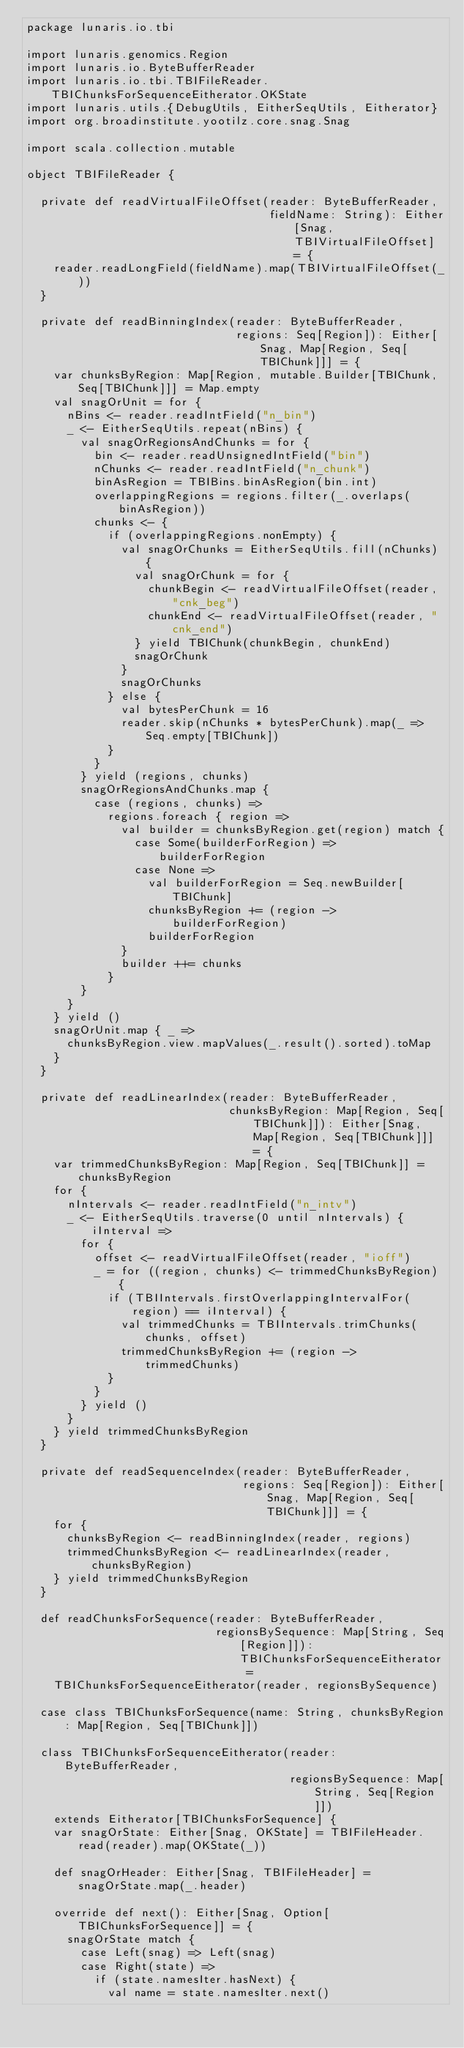Convert code to text. <code><loc_0><loc_0><loc_500><loc_500><_Scala_>package lunaris.io.tbi

import lunaris.genomics.Region
import lunaris.io.ByteBufferReader
import lunaris.io.tbi.TBIFileReader.TBIChunksForSequenceEitherator.OKState
import lunaris.utils.{DebugUtils, EitherSeqUtils, Eitherator}
import org.broadinstitute.yootilz.core.snag.Snag

import scala.collection.mutable

object TBIFileReader {

  private def readVirtualFileOffset(reader: ByteBufferReader,
                                    fieldName: String): Either[Snag, TBIVirtualFileOffset] = {
    reader.readLongField(fieldName).map(TBIVirtualFileOffset(_))
  }

  private def readBinningIndex(reader: ByteBufferReader,
                               regions: Seq[Region]): Either[Snag, Map[Region, Seq[TBIChunk]]] = {
    var chunksByRegion: Map[Region, mutable.Builder[TBIChunk, Seq[TBIChunk]]] = Map.empty
    val snagOrUnit = for {
      nBins <- reader.readIntField("n_bin")
      _ <- EitherSeqUtils.repeat(nBins) {
        val snagOrRegionsAndChunks = for {
          bin <- reader.readUnsignedIntField("bin")
          nChunks <- reader.readIntField("n_chunk")
          binAsRegion = TBIBins.binAsRegion(bin.int)
          overlappingRegions = regions.filter(_.overlaps(binAsRegion))
          chunks <- {
            if (overlappingRegions.nonEmpty) {
              val snagOrChunks = EitherSeqUtils.fill(nChunks) {
                val snagOrChunk = for {
                  chunkBegin <- readVirtualFileOffset(reader, "cnk_beg")
                  chunkEnd <- readVirtualFileOffset(reader, "cnk_end")
                } yield TBIChunk(chunkBegin, chunkEnd)
                snagOrChunk
              }
              snagOrChunks
            } else {
              val bytesPerChunk = 16
              reader.skip(nChunks * bytesPerChunk).map(_ => Seq.empty[TBIChunk])
            }
          }
        } yield (regions, chunks)
        snagOrRegionsAndChunks.map {
          case (regions, chunks) =>
            regions.foreach { region =>
              val builder = chunksByRegion.get(region) match {
                case Some(builderForRegion) => builderForRegion
                case None =>
                  val builderForRegion = Seq.newBuilder[TBIChunk]
                  chunksByRegion += (region -> builderForRegion)
                  builderForRegion
              }
              builder ++= chunks
            }
        }
      }
    } yield ()
    snagOrUnit.map { _ =>
      chunksByRegion.view.mapValues(_.result().sorted).toMap
    }
  }

  private def readLinearIndex(reader: ByteBufferReader,
                              chunksByRegion: Map[Region, Seq[TBIChunk]]): Either[Snag, Map[Region, Seq[TBIChunk]]] = {
    var trimmedChunksByRegion: Map[Region, Seq[TBIChunk]] = chunksByRegion
    for {
      nIntervals <- reader.readIntField("n_intv")
      _ <- EitherSeqUtils.traverse(0 until nIntervals) { iInterval =>
        for {
          offset <- readVirtualFileOffset(reader, "ioff")
          _ = for ((region, chunks) <- trimmedChunksByRegion) {
            if (TBIIntervals.firstOverlappingIntervalFor(region) == iInterval) {
              val trimmedChunks = TBIIntervals.trimChunks(chunks, offset)
              trimmedChunksByRegion += (region -> trimmedChunks)
            }
          }
        } yield ()
      }
    } yield trimmedChunksByRegion
  }

  private def readSequenceIndex(reader: ByteBufferReader,
                                regions: Seq[Region]): Either[Snag, Map[Region, Seq[TBIChunk]]] = {
    for {
      chunksByRegion <- readBinningIndex(reader, regions)
      trimmedChunksByRegion <- readLinearIndex(reader, chunksByRegion)
    } yield trimmedChunksByRegion
  }

  def readChunksForSequence(reader: ByteBufferReader,
                            regionsBySequence: Map[String, Seq[Region]]): TBIChunksForSequenceEitherator =
    TBIChunksForSequenceEitherator(reader, regionsBySequence)

  case class TBIChunksForSequence(name: String, chunksByRegion: Map[Region, Seq[TBIChunk]])

  class TBIChunksForSequenceEitherator(reader: ByteBufferReader,
                                       regionsBySequence: Map[String, Seq[Region]])
    extends Eitherator[TBIChunksForSequence] {
    var snagOrState: Either[Snag, OKState] = TBIFileHeader.read(reader).map(OKState(_))

    def snagOrHeader: Either[Snag, TBIFileHeader] = snagOrState.map(_.header)

    override def next(): Either[Snag, Option[TBIChunksForSequence]] = {
      snagOrState match {
        case Left(snag) => Left(snag)
        case Right(state) =>
          if (state.namesIter.hasNext) {
            val name = state.namesIter.next()</code> 